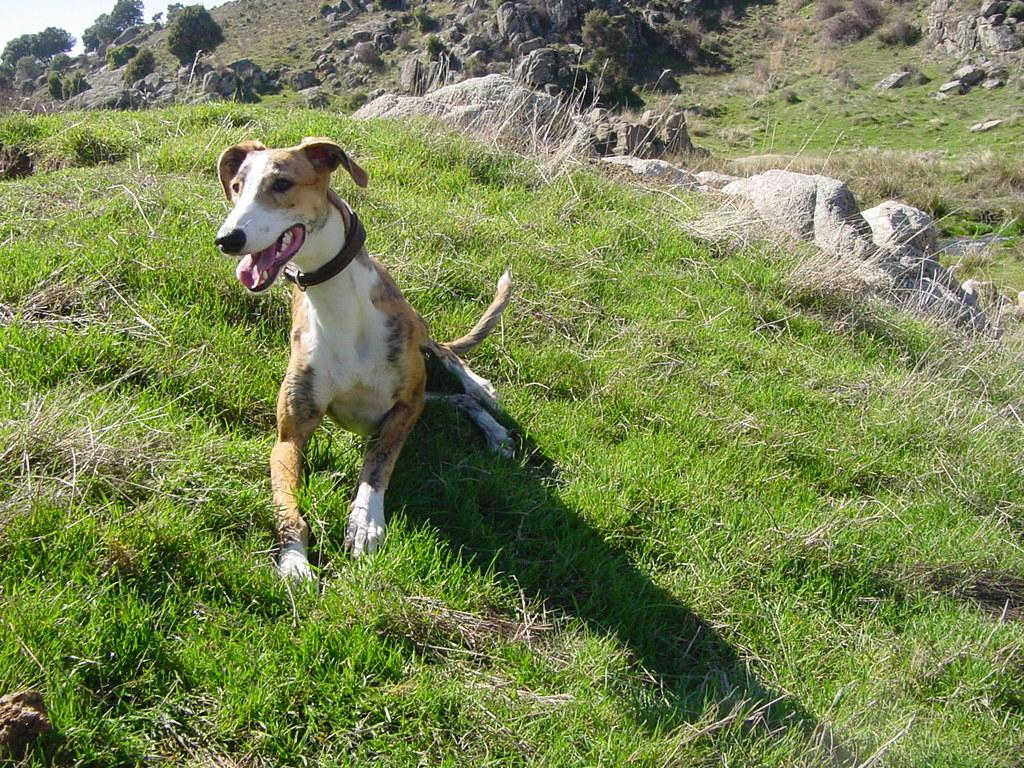What type of animal is in the image? There is a dog in the image. Can you describe the dog's appearance? The dog is white and brown in color. What is the dog wearing around its neck? The dog has a belt around its neck. What type of terrain is visible in the image? There are rocks, trees, and grass on the ground in the image. How many kittens are playing with the dog in the image? There are no kittens present in the image; it only features a dog. What type of group is shown interacting with the dog in the image? There is no group present in the image; the dog is the only animal visible. 